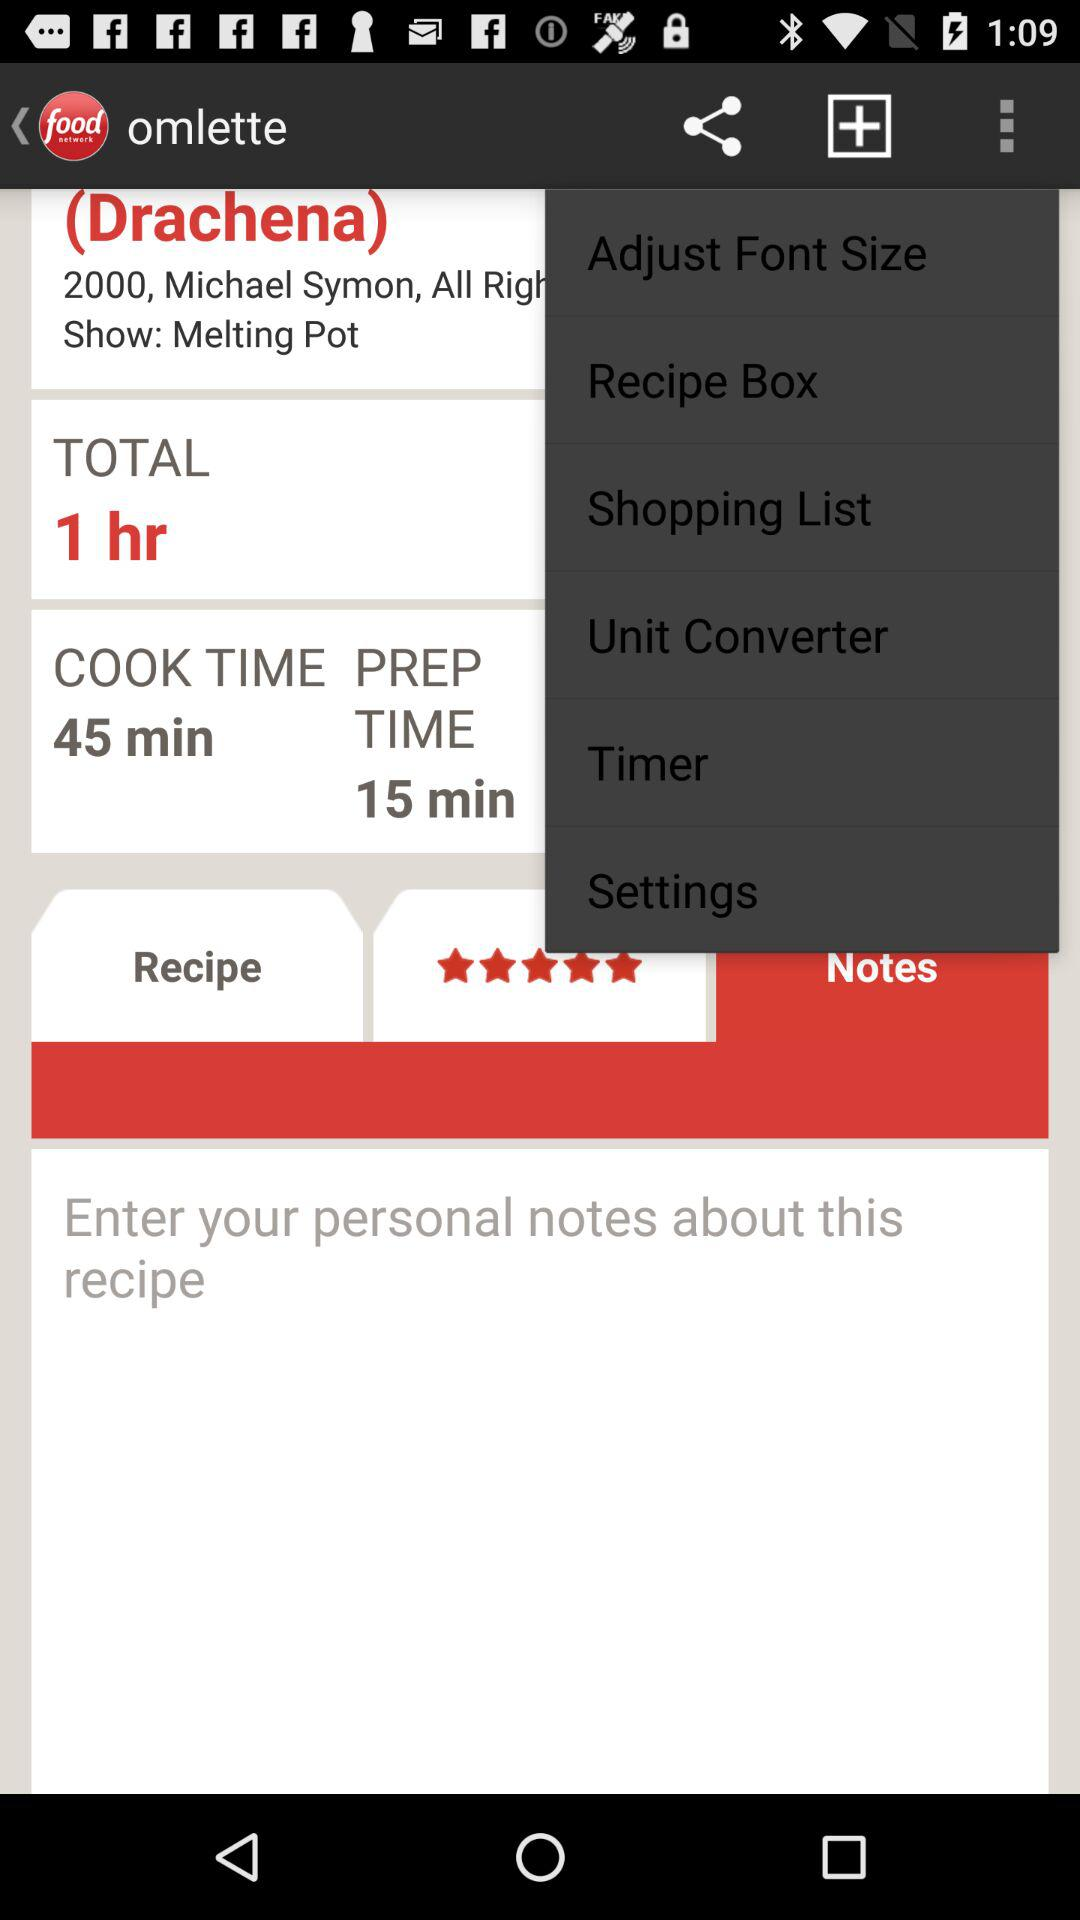What is the total time? The total time is 1 hour. 